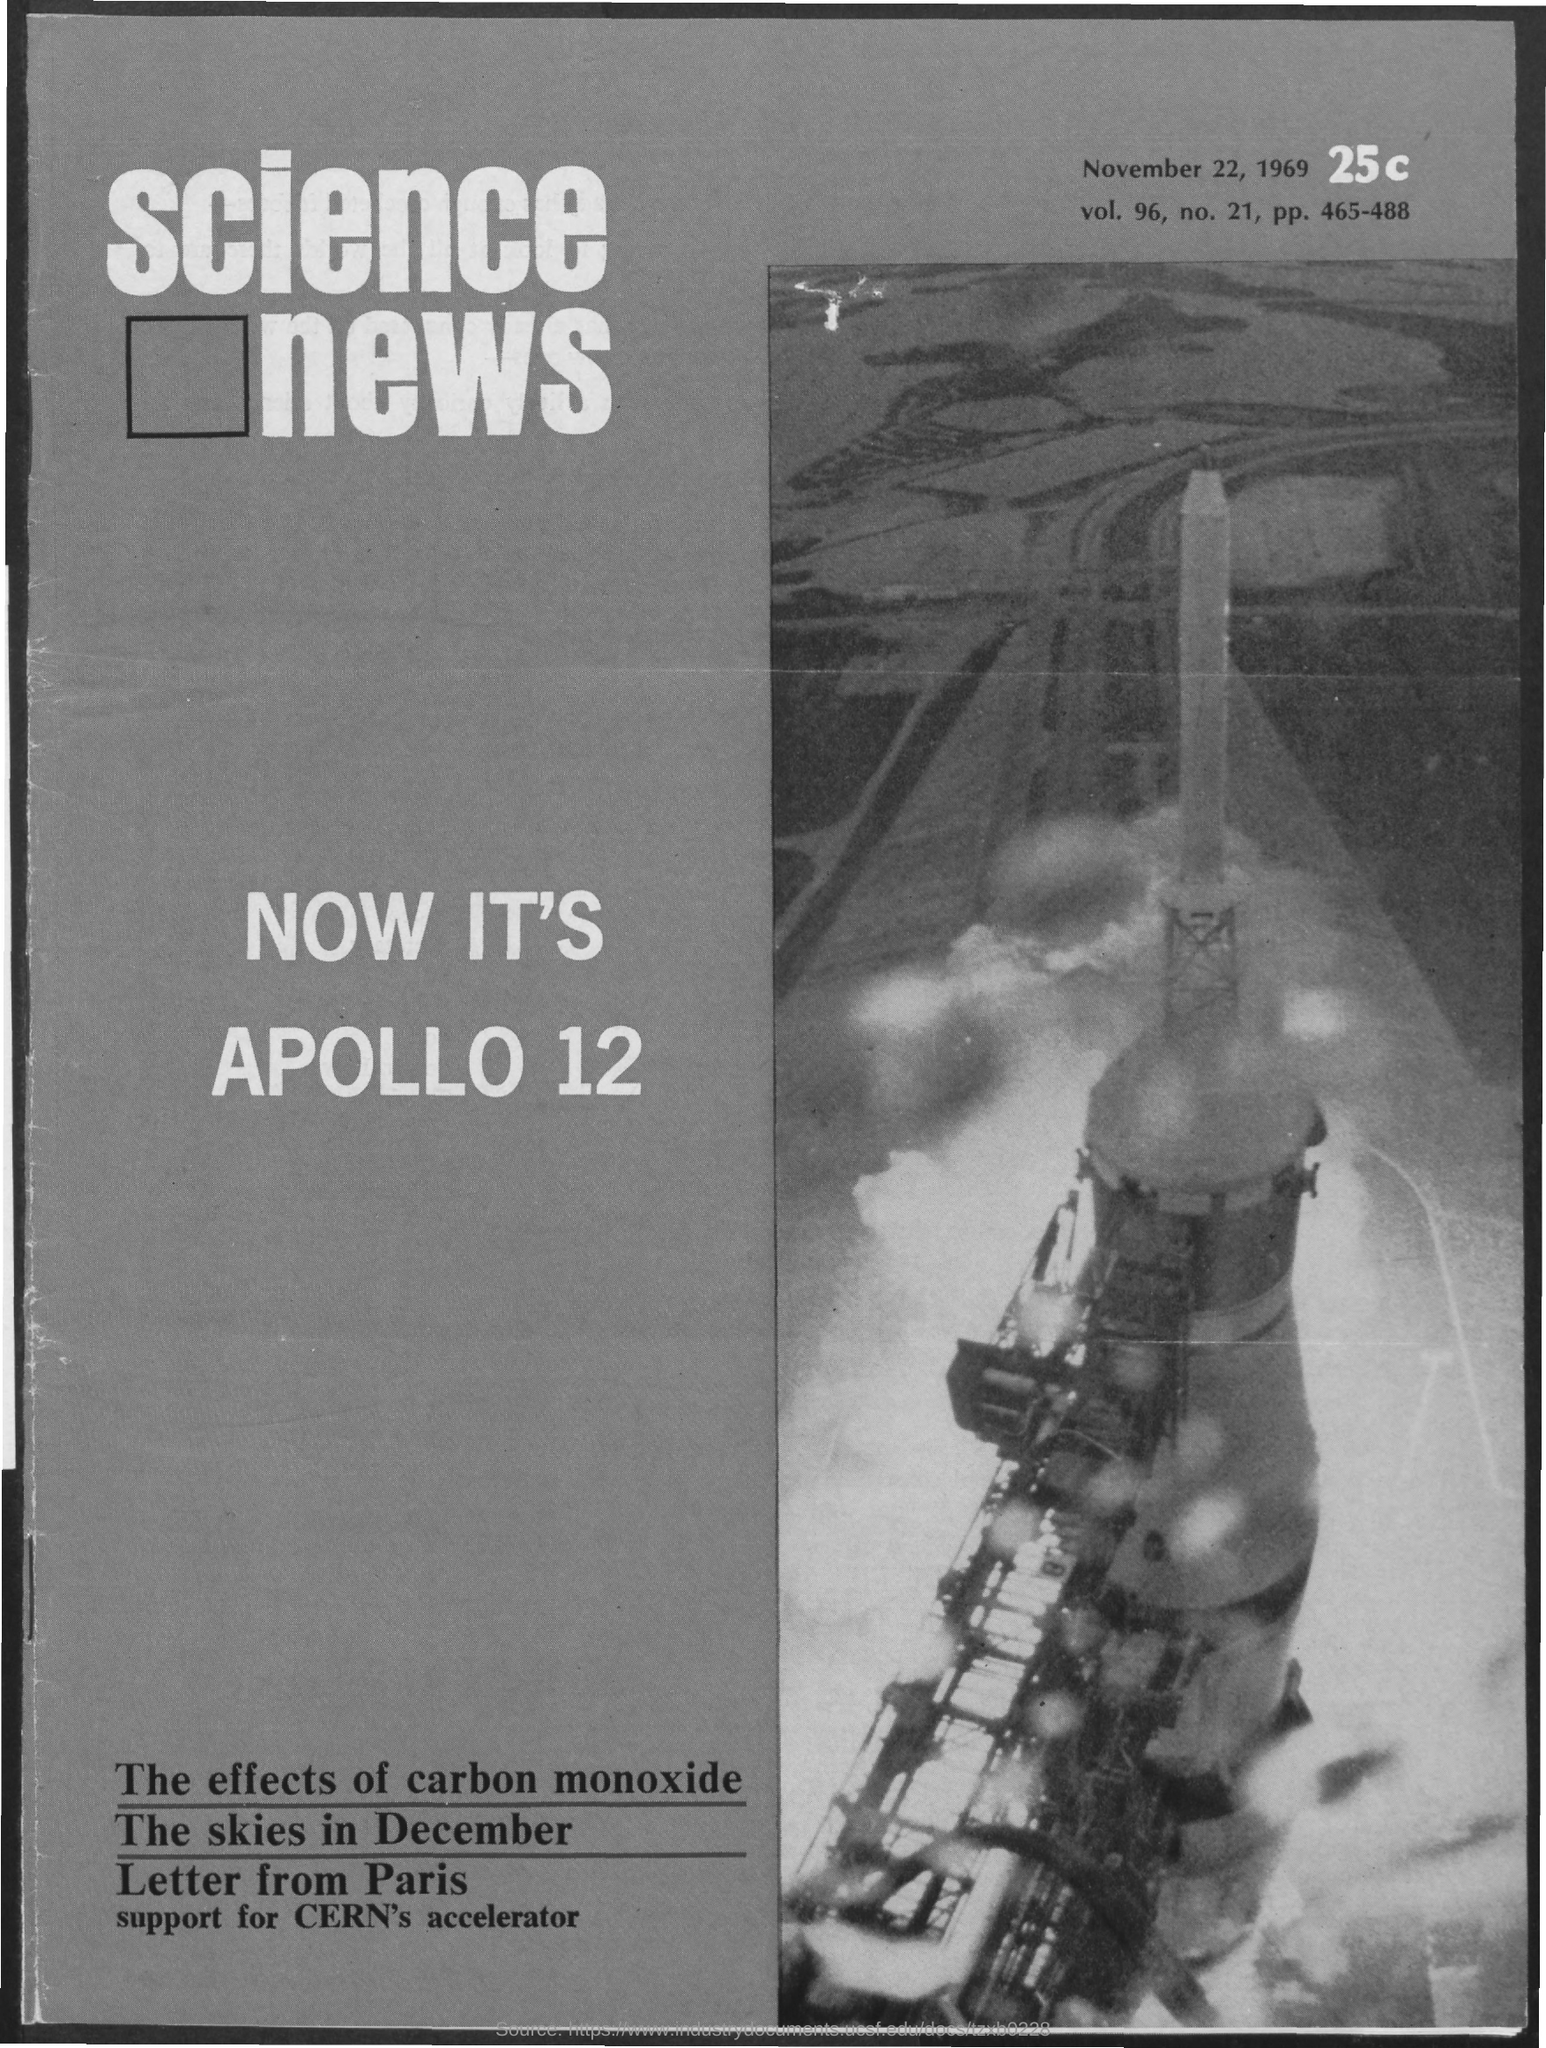What is the date on the document?
Provide a succinct answer. NOVEMBER 22, 1969. What is the Vol.?
Provide a succinct answer. 96. What is the No.?
Your answer should be compact. 21. What is the pp.?
Your answer should be very brief. 465-488. 